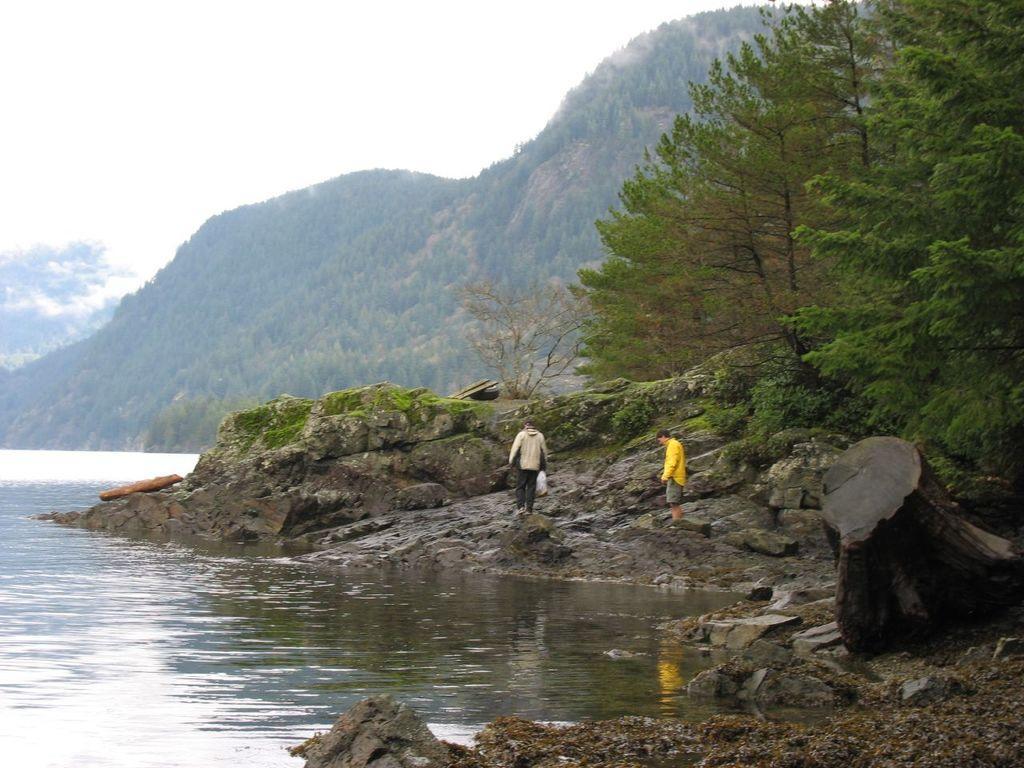Could you give a brief overview of what you see in this image? In this age we can see persons standing on the rocks, hills, trees, water and sky with clouds. 